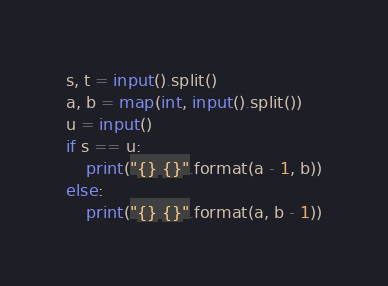Convert code to text. <code><loc_0><loc_0><loc_500><loc_500><_Python_>s, t = input().split()
a, b = map(int, input().split())
u = input()
if s == u:
    print("{} {}".format(a - 1, b))
else:
    print("{} {}".format(a, b - 1))</code> 